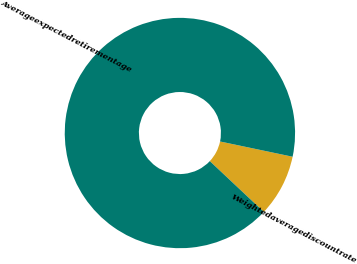Convert chart. <chart><loc_0><loc_0><loc_500><loc_500><pie_chart><fcel>Weightedaveragediscountrate<fcel>Averageexpectedretirementage<nl><fcel>8.71%<fcel>91.29%<nl></chart> 